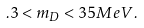Convert formula to latex. <formula><loc_0><loc_0><loc_500><loc_500>. 3 < m _ { D } < 3 5 M e V .</formula> 